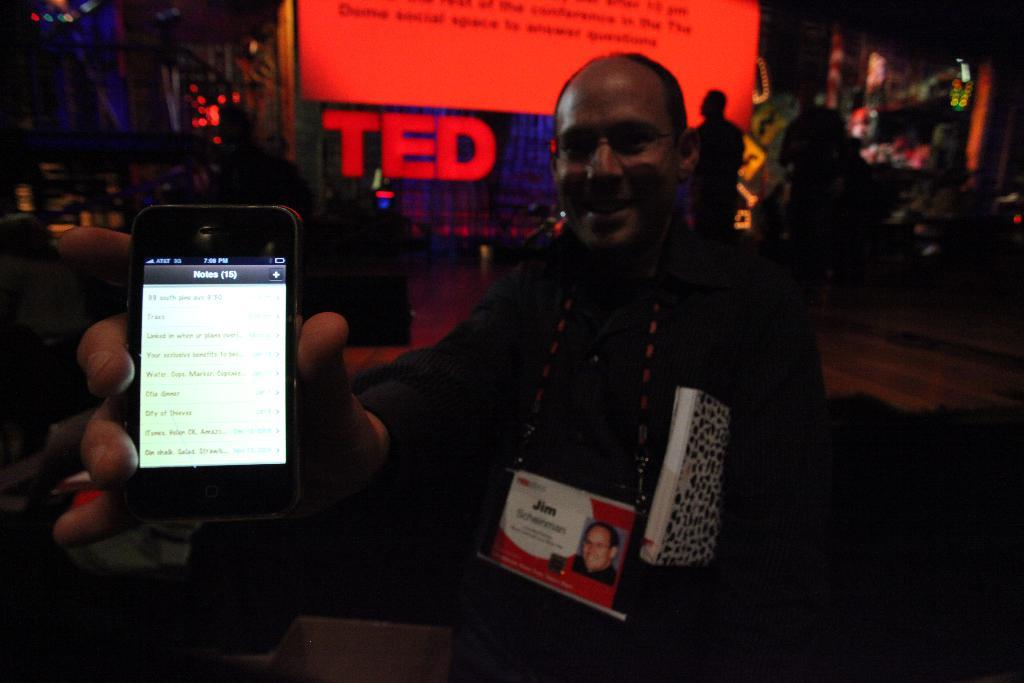<image>
Write a terse but informative summary of the picture. a man standing near a large Ted talk sign 